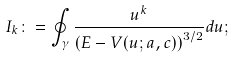<formula> <loc_0><loc_0><loc_500><loc_500>I _ { k } \colon = \oint _ { \gamma } \frac { u ^ { k } } { \left ( E - V ( u ; a , c ) \right ) ^ { 3 / 2 } } d u ;</formula> 